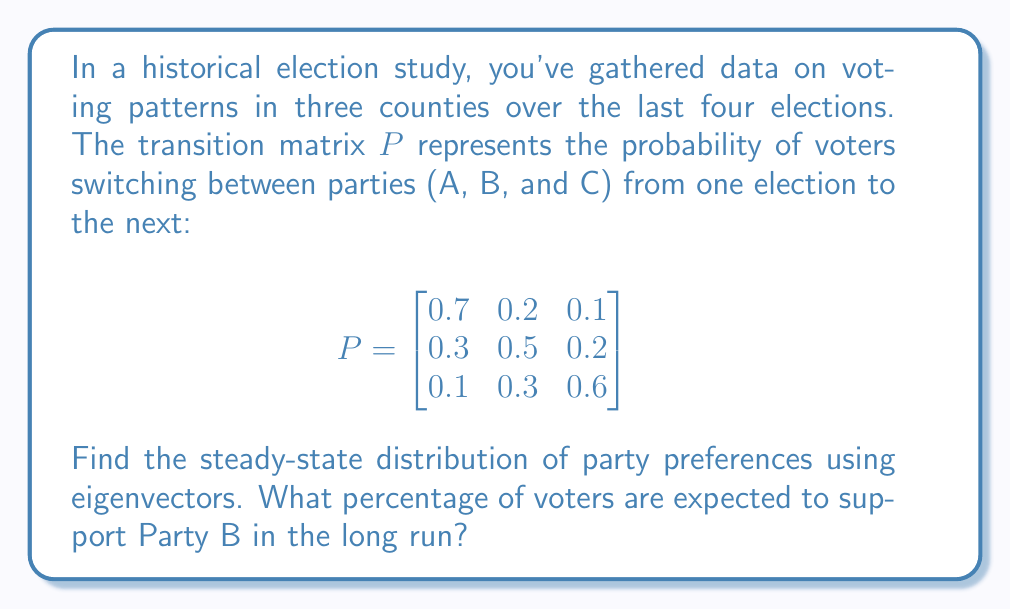Help me with this question. To find the steady-state distribution, we need to solve for the eigenvector corresponding to the eigenvalue 1 of the transition matrix P.

1. First, we verify that 1 is indeed an eigenvalue of P:
   $\det(P - I) = 0$, where I is the 3x3 identity matrix.

2. Next, we solve the equation $(P - I)\mathbf{v} = \mathbf{0}$:

   $$\begin{bmatrix}
   -0.3 & 0.2 & 0.1 \\
   0.3 & -0.5 & 0.2 \\
   0.1 & 0.3 & -0.4
   \end{bmatrix}\begin{bmatrix}
   v_1 \\ v_2 \\ v_3
   \end{bmatrix} = \begin{bmatrix}
   0 \\ 0 \\ 0
   \end{bmatrix}$$

3. This gives us the system of equations:
   $-0.3v_1 + 0.2v_2 + 0.1v_3 = 0$
   $0.3v_1 - 0.5v_2 + 0.2v_3 = 0$
   $0.1v_1 + 0.3v_2 - 0.4v_3 = 0$

4. Solving this system (e.g., by substitution or elimination), we get:
   $v_1 : v_2 : v_3 = 5 : 3 : 2$

5. To make this a probability distribution, we normalize it so the sum equals 1:
   $5 + 3 + 2 = 10$
   
   Therefore, the steady-state distribution is:
   $\mathbf{v} = (\frac{5}{10}, \frac{3}{10}, \frac{2}{10}) = (0.5, 0.3, 0.2)$

6. The second component of this vector represents the long-term proportion of voters supporting Party B.
Answer: In the long run, 30% or 0.3 of voters are expected to support Party B. 